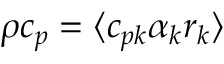<formula> <loc_0><loc_0><loc_500><loc_500>\rho c _ { p } = \langle c _ { p k } \alpha _ { k } r _ { k } \rangle</formula> 